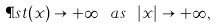Convert formula to latex. <formula><loc_0><loc_0><loc_500><loc_500>\P s t ( x ) \to + \infty \ a s \ | x | \to + \infty ,</formula> 